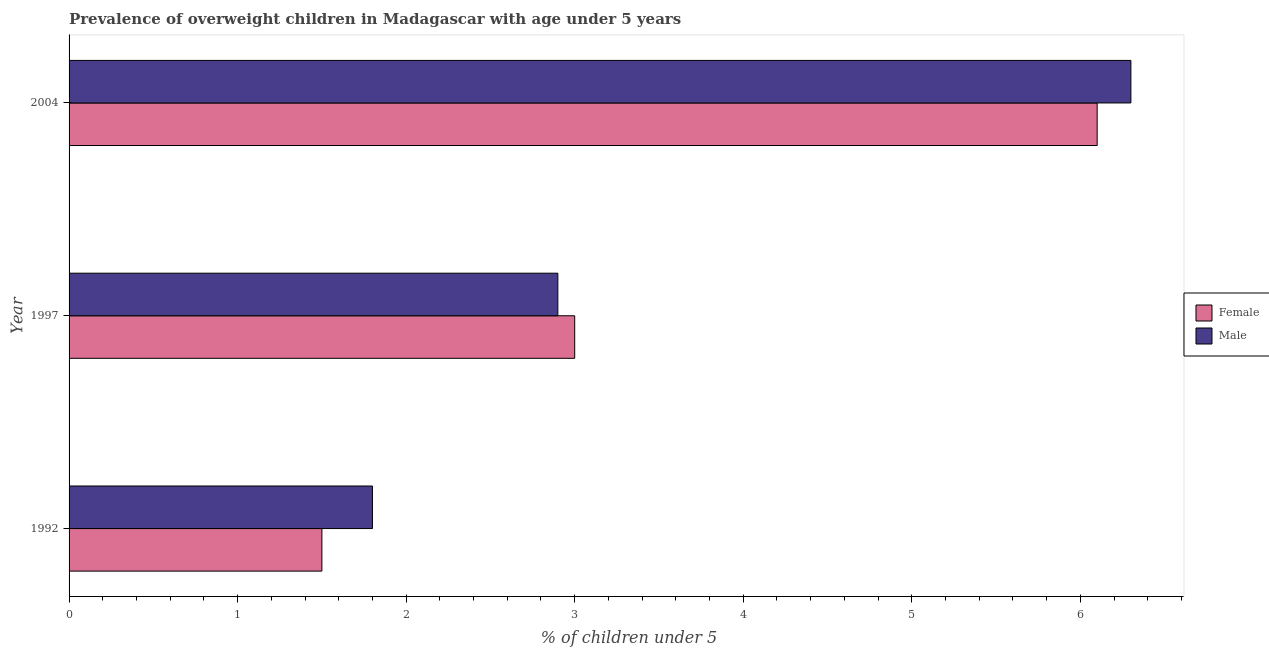How many different coloured bars are there?
Provide a short and direct response. 2. How many bars are there on the 3rd tick from the top?
Provide a succinct answer. 2. What is the label of the 3rd group of bars from the top?
Give a very brief answer. 1992. In how many cases, is the number of bars for a given year not equal to the number of legend labels?
Offer a very short reply. 0. What is the percentage of obese male children in 2004?
Give a very brief answer. 6.3. Across all years, what is the maximum percentage of obese male children?
Offer a very short reply. 6.3. Across all years, what is the minimum percentage of obese male children?
Provide a short and direct response. 1.8. In which year was the percentage of obese female children maximum?
Your response must be concise. 2004. What is the total percentage of obese female children in the graph?
Provide a succinct answer. 10.6. What is the difference between the percentage of obese female children in 1992 and that in 1997?
Offer a terse response. -1.5. What is the difference between the percentage of obese male children in 1997 and the percentage of obese female children in 2004?
Provide a succinct answer. -3.2. What is the average percentage of obese female children per year?
Offer a very short reply. 3.53. What is the ratio of the percentage of obese male children in 1992 to that in 1997?
Your answer should be compact. 0.62. Is the difference between the percentage of obese male children in 1992 and 1997 greater than the difference between the percentage of obese female children in 1992 and 1997?
Make the answer very short. Yes. What is the difference between the highest and the lowest percentage of obese male children?
Provide a succinct answer. 4.5. In how many years, is the percentage of obese female children greater than the average percentage of obese female children taken over all years?
Offer a terse response. 1. What does the 2nd bar from the top in 1997 represents?
Your response must be concise. Female. Are all the bars in the graph horizontal?
Offer a terse response. Yes. How many years are there in the graph?
Offer a terse response. 3. What is the difference between two consecutive major ticks on the X-axis?
Ensure brevity in your answer.  1. Does the graph contain any zero values?
Make the answer very short. No. Does the graph contain grids?
Make the answer very short. No. What is the title of the graph?
Keep it short and to the point. Prevalence of overweight children in Madagascar with age under 5 years. Does "Female labor force" appear as one of the legend labels in the graph?
Keep it short and to the point. No. What is the label or title of the X-axis?
Your response must be concise.  % of children under 5. What is the  % of children under 5 of Female in 1992?
Your response must be concise. 1.5. What is the  % of children under 5 in Male in 1992?
Keep it short and to the point. 1.8. What is the  % of children under 5 in Female in 1997?
Your answer should be compact. 3. What is the  % of children under 5 of Male in 1997?
Keep it short and to the point. 2.9. What is the  % of children under 5 in Female in 2004?
Provide a short and direct response. 6.1. What is the  % of children under 5 in Male in 2004?
Ensure brevity in your answer.  6.3. Across all years, what is the maximum  % of children under 5 of Female?
Offer a terse response. 6.1. Across all years, what is the maximum  % of children under 5 in Male?
Keep it short and to the point. 6.3. Across all years, what is the minimum  % of children under 5 in Male?
Your answer should be compact. 1.8. What is the total  % of children under 5 of Female in the graph?
Give a very brief answer. 10.6. What is the total  % of children under 5 of Male in the graph?
Offer a terse response. 11. What is the difference between the  % of children under 5 in Female in 1992 and that in 2004?
Provide a succinct answer. -4.6. What is the difference between the  % of children under 5 of Female in 1992 and the  % of children under 5 of Male in 1997?
Your answer should be very brief. -1.4. What is the difference between the  % of children under 5 in Female in 1992 and the  % of children under 5 in Male in 2004?
Provide a succinct answer. -4.8. What is the average  % of children under 5 of Female per year?
Provide a succinct answer. 3.53. What is the average  % of children under 5 of Male per year?
Provide a short and direct response. 3.67. In the year 1992, what is the difference between the  % of children under 5 in Female and  % of children under 5 in Male?
Your answer should be compact. -0.3. What is the ratio of the  % of children under 5 of Female in 1992 to that in 1997?
Your answer should be very brief. 0.5. What is the ratio of the  % of children under 5 in Male in 1992 to that in 1997?
Ensure brevity in your answer.  0.62. What is the ratio of the  % of children under 5 of Female in 1992 to that in 2004?
Ensure brevity in your answer.  0.25. What is the ratio of the  % of children under 5 in Male in 1992 to that in 2004?
Make the answer very short. 0.29. What is the ratio of the  % of children under 5 of Female in 1997 to that in 2004?
Your answer should be very brief. 0.49. What is the ratio of the  % of children under 5 of Male in 1997 to that in 2004?
Your response must be concise. 0.46. What is the difference between the highest and the second highest  % of children under 5 in Male?
Ensure brevity in your answer.  3.4. What is the difference between the highest and the lowest  % of children under 5 of Male?
Offer a terse response. 4.5. 